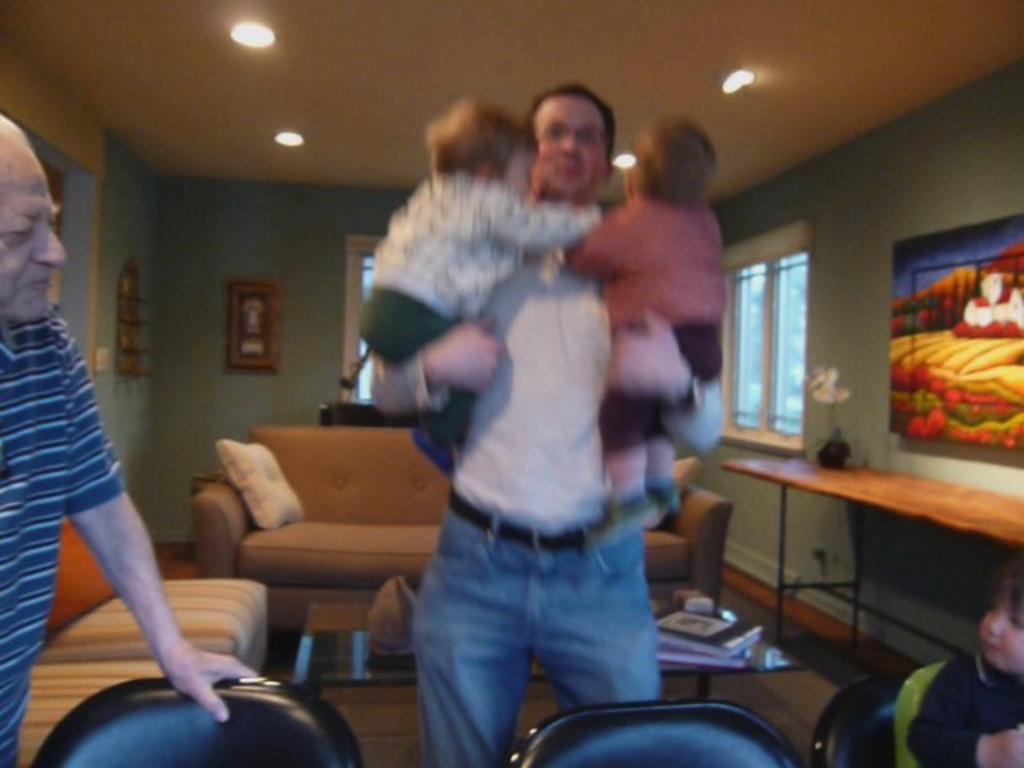In one or two sentences, can you explain what this image depicts? a person is standing wearing a white shirt and blue jeans, holding 2 babies in his hand. a person is standing at the left wearing a t shirt. there are 3 black chairs in the front. a person is sitting on the right chair wearing a black t shirt. at the back there is a sofa and a table on which there are books. behind that there is a green wall on which there are photo frames, windows at the back. at the right there is a table on which there is a flower pot. behind that there is a frame on the wall and a window. there are lights on the roofs. 